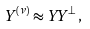<formula> <loc_0><loc_0><loc_500><loc_500>Y ^ { ( \nu ) } \approx Y Y ^ { \bot } \, ,</formula> 